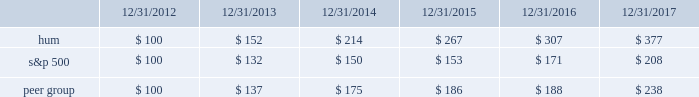Stock total return performance the following graph compares our total return to stockholders with the returns of the standard & poor 2019s composite 500 index ( 201cs&p 500 201d ) and the dow jones us select health care providers index ( 201cpeer group 201d ) for the five years ended december 31 , 2017 .
The graph assumes an investment of $ 100 in each of our common stock , the s&p 500 , and the peer group on december 31 , 2012 , and that dividends were reinvested when paid. .
The stock price performance included in this graph is not necessarily indicative of future stock price performance. .
What is the increase observed in the return of the second year of the investment for peer group? 
Rationale: it is the value of the investment in the second year divided by the first year's , then turned into a percentage .
Computations: ((175 / 137) - 1)
Answer: 0.27737. 